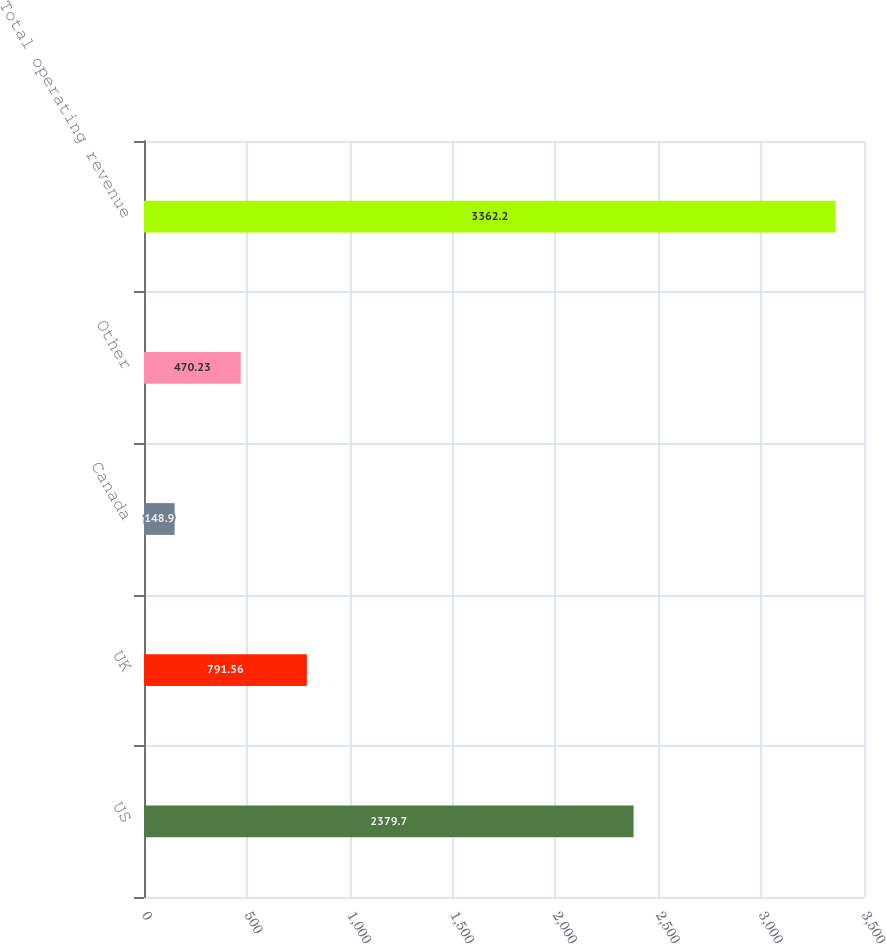Convert chart. <chart><loc_0><loc_0><loc_500><loc_500><bar_chart><fcel>US<fcel>UK<fcel>Canada<fcel>Other<fcel>Total operating revenue<nl><fcel>2379.7<fcel>791.56<fcel>148.9<fcel>470.23<fcel>3362.2<nl></chart> 